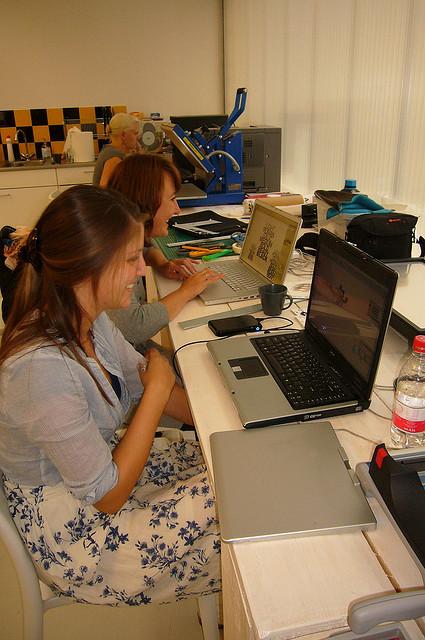Are these computers on or off?
Answer briefly. On. Are the girls enjoying themselves?
Keep it brief. Yes. Is she making something?
Concise answer only. No. 